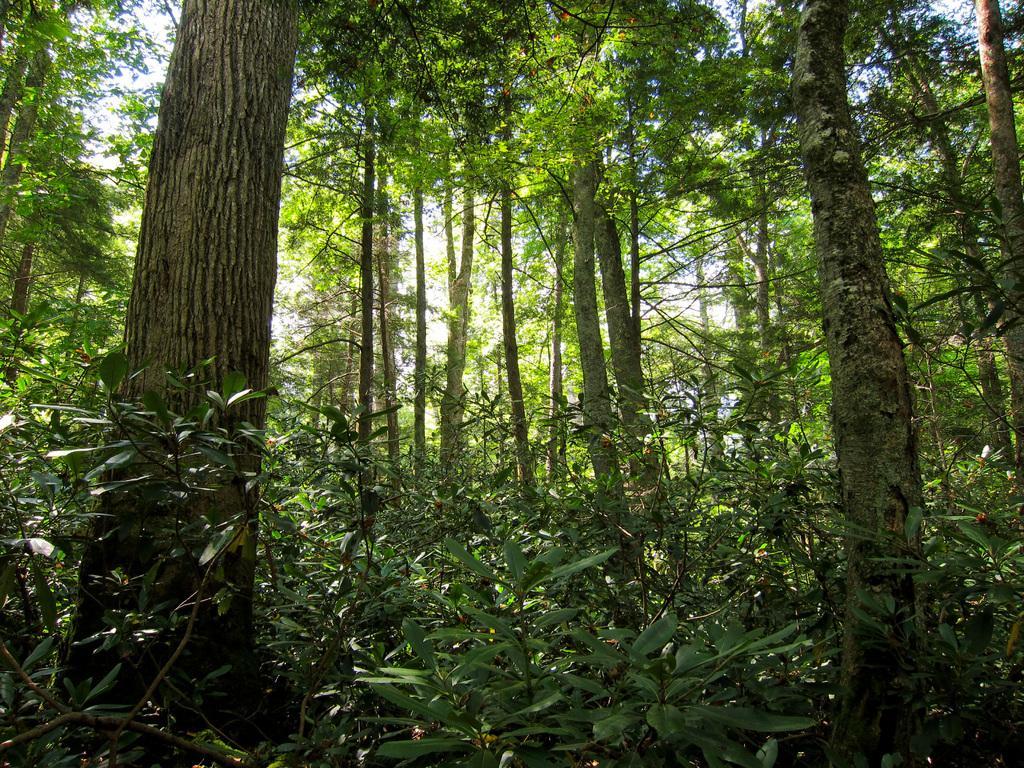Can you describe this image briefly? In this image we can see some trees and plants, in the background, we can see the sky. 